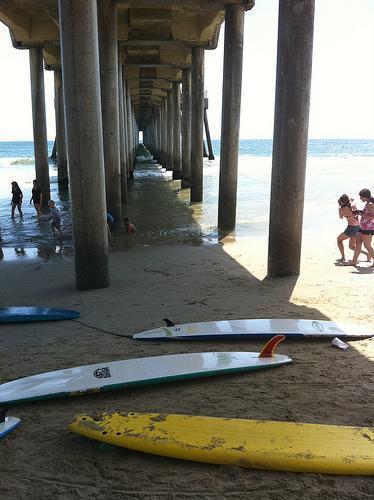How many people are there?
Give a very brief answer. 7. How many surboards are there?
Give a very brief answer. 5. 